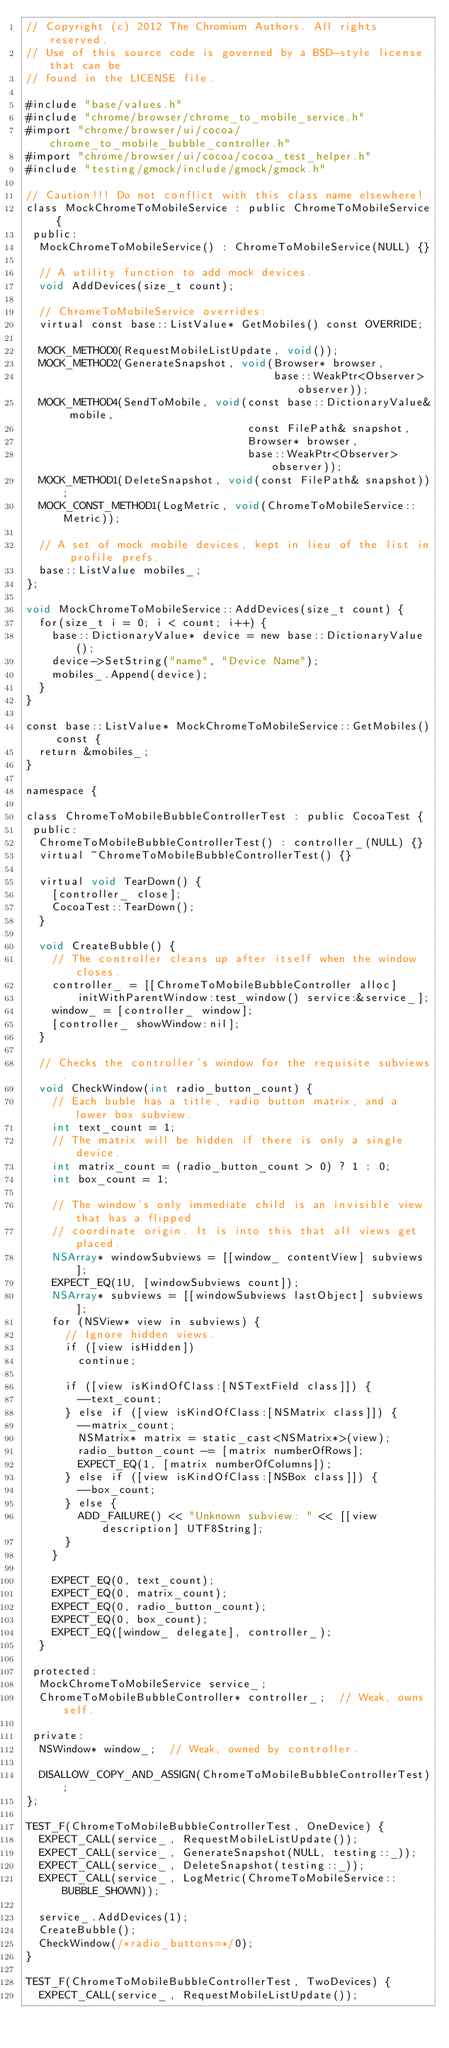<code> <loc_0><loc_0><loc_500><loc_500><_ObjectiveC_>// Copyright (c) 2012 The Chromium Authors. All rights reserved.
// Use of this source code is governed by a BSD-style license that can be
// found in the LICENSE file.

#include "base/values.h"
#include "chrome/browser/chrome_to_mobile_service.h"
#import "chrome/browser/ui/cocoa/chrome_to_mobile_bubble_controller.h"
#import "chrome/browser/ui/cocoa/cocoa_test_helper.h"
#include "testing/gmock/include/gmock/gmock.h"

// Caution!!! Do not conflict with this class name elsewhere!
class MockChromeToMobileService : public ChromeToMobileService {
 public:
  MockChromeToMobileService() : ChromeToMobileService(NULL) {}

  // A utility function to add mock devices.
  void AddDevices(size_t count);

  // ChromeToMobileService overrides:
  virtual const base::ListValue* GetMobiles() const OVERRIDE;

  MOCK_METHOD0(RequestMobileListUpdate, void());
  MOCK_METHOD2(GenerateSnapshot, void(Browser* browser,
                                      base::WeakPtr<Observer> observer));
  MOCK_METHOD4(SendToMobile, void(const base::DictionaryValue& mobile,
                                  const FilePath& snapshot,
                                  Browser* browser,
                                  base::WeakPtr<Observer> observer));
  MOCK_METHOD1(DeleteSnapshot, void(const FilePath& snapshot));
  MOCK_CONST_METHOD1(LogMetric, void(ChromeToMobileService::Metric));

  // A set of mock mobile devices, kept in lieu of the list in profile prefs.
  base::ListValue mobiles_;
};

void MockChromeToMobileService::AddDevices(size_t count) {
  for(size_t i = 0; i < count; i++) {
    base::DictionaryValue* device = new base::DictionaryValue();
    device->SetString("name", "Device Name");
    mobiles_.Append(device);
  }
}

const base::ListValue* MockChromeToMobileService::GetMobiles() const {
  return &mobiles_;
}

namespace {

class ChromeToMobileBubbleControllerTest : public CocoaTest {
 public:
  ChromeToMobileBubbleControllerTest() : controller_(NULL) {}
  virtual ~ChromeToMobileBubbleControllerTest() {}

  virtual void TearDown() {
    [controller_ close];
    CocoaTest::TearDown();
  }

  void CreateBubble() {
    // The controller cleans up after itself when the window closes.
    controller_ = [[ChromeToMobileBubbleController alloc]
        initWithParentWindow:test_window() service:&service_];
    window_ = [controller_ window];
    [controller_ showWindow:nil];
  }

  // Checks the controller's window for the requisite subviews.
  void CheckWindow(int radio_button_count) {
    // Each buble has a title, radio button matrix, and a lower box subview.
    int text_count = 1;
    // The matrix will be hidden if there is only a single device.
    int matrix_count = (radio_button_count > 0) ? 1 : 0;
    int box_count = 1;

    // The window's only immediate child is an invisible view that has a flipped
    // coordinate origin. It is into this that all views get placed.
    NSArray* windowSubviews = [[window_ contentView] subviews];
    EXPECT_EQ(1U, [windowSubviews count]);
    NSArray* subviews = [[windowSubviews lastObject] subviews];
    for (NSView* view in subviews) {
      // Ignore hidden views.
      if ([view isHidden])
        continue;

      if ([view isKindOfClass:[NSTextField class]]) {
        --text_count;
      } else if ([view isKindOfClass:[NSMatrix class]]) {
        --matrix_count;
        NSMatrix* matrix = static_cast<NSMatrix*>(view);
        radio_button_count -= [matrix numberOfRows];
        EXPECT_EQ(1, [matrix numberOfColumns]);
      } else if ([view isKindOfClass:[NSBox class]]) {
        --box_count;
      } else {
        ADD_FAILURE() << "Unknown subview: " << [[view description] UTF8String];
      }
    }

    EXPECT_EQ(0, text_count);
    EXPECT_EQ(0, matrix_count);
    EXPECT_EQ(0, radio_button_count);
    EXPECT_EQ(0, box_count);
    EXPECT_EQ([window_ delegate], controller_);
  }

 protected:
  MockChromeToMobileService service_;
  ChromeToMobileBubbleController* controller_;  // Weak, owns self.

 private:
  NSWindow* window_;  // Weak, owned by controller.

  DISALLOW_COPY_AND_ASSIGN(ChromeToMobileBubbleControllerTest);
};

TEST_F(ChromeToMobileBubbleControllerTest, OneDevice) {
  EXPECT_CALL(service_, RequestMobileListUpdate());
  EXPECT_CALL(service_, GenerateSnapshot(NULL, testing::_));
  EXPECT_CALL(service_, DeleteSnapshot(testing::_));
  EXPECT_CALL(service_, LogMetric(ChromeToMobileService::BUBBLE_SHOWN));

  service_.AddDevices(1);
  CreateBubble();
  CheckWindow(/*radio_buttons=*/0);
}

TEST_F(ChromeToMobileBubbleControllerTest, TwoDevices) {
  EXPECT_CALL(service_, RequestMobileListUpdate());</code> 